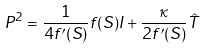<formula> <loc_0><loc_0><loc_500><loc_500>P ^ { 2 } = \frac { 1 } { 4 f ^ { \prime } ( S ) } f ( S ) I + \frac { \kappa } { 2 f ^ { \prime } ( S ) } \hat { T }</formula> 